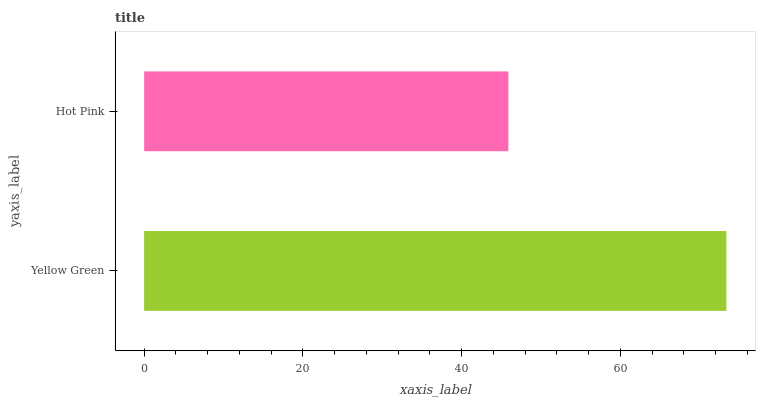Is Hot Pink the minimum?
Answer yes or no. Yes. Is Yellow Green the maximum?
Answer yes or no. Yes. Is Hot Pink the maximum?
Answer yes or no. No. Is Yellow Green greater than Hot Pink?
Answer yes or no. Yes. Is Hot Pink less than Yellow Green?
Answer yes or no. Yes. Is Hot Pink greater than Yellow Green?
Answer yes or no. No. Is Yellow Green less than Hot Pink?
Answer yes or no. No. Is Yellow Green the high median?
Answer yes or no. Yes. Is Hot Pink the low median?
Answer yes or no. Yes. Is Hot Pink the high median?
Answer yes or no. No. Is Yellow Green the low median?
Answer yes or no. No. 